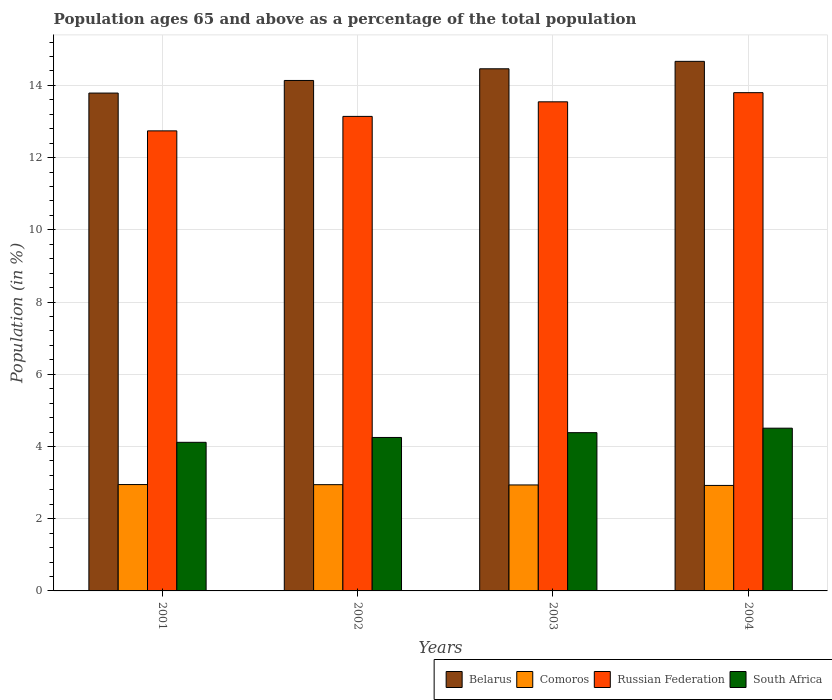How many groups of bars are there?
Give a very brief answer. 4. Are the number of bars per tick equal to the number of legend labels?
Your response must be concise. Yes. Are the number of bars on each tick of the X-axis equal?
Ensure brevity in your answer.  Yes. How many bars are there on the 3rd tick from the left?
Offer a very short reply. 4. What is the label of the 1st group of bars from the left?
Provide a short and direct response. 2001. What is the percentage of the population ages 65 and above in South Africa in 2002?
Provide a succinct answer. 4.25. Across all years, what is the maximum percentage of the population ages 65 and above in Belarus?
Provide a succinct answer. 14.67. Across all years, what is the minimum percentage of the population ages 65 and above in Comoros?
Keep it short and to the point. 2.92. In which year was the percentage of the population ages 65 and above in Comoros maximum?
Provide a succinct answer. 2001. In which year was the percentage of the population ages 65 and above in Comoros minimum?
Provide a short and direct response. 2004. What is the total percentage of the population ages 65 and above in South Africa in the graph?
Make the answer very short. 17.26. What is the difference between the percentage of the population ages 65 and above in Belarus in 2001 and that in 2004?
Ensure brevity in your answer.  -0.88. What is the difference between the percentage of the population ages 65 and above in South Africa in 2003 and the percentage of the population ages 65 and above in Comoros in 2002?
Give a very brief answer. 1.44. What is the average percentage of the population ages 65 and above in Russian Federation per year?
Keep it short and to the point. 13.31. In the year 2003, what is the difference between the percentage of the population ages 65 and above in Comoros and percentage of the population ages 65 and above in South Africa?
Offer a very short reply. -1.45. In how many years, is the percentage of the population ages 65 and above in Belarus greater than 2.8?
Your answer should be very brief. 4. What is the ratio of the percentage of the population ages 65 and above in South Africa in 2002 to that in 2004?
Give a very brief answer. 0.94. Is the percentage of the population ages 65 and above in South Africa in 2001 less than that in 2003?
Your answer should be very brief. Yes. What is the difference between the highest and the second highest percentage of the population ages 65 and above in Russian Federation?
Your answer should be very brief. 0.25. What is the difference between the highest and the lowest percentage of the population ages 65 and above in South Africa?
Ensure brevity in your answer.  0.39. In how many years, is the percentage of the population ages 65 and above in South Africa greater than the average percentage of the population ages 65 and above in South Africa taken over all years?
Ensure brevity in your answer.  2. Is it the case that in every year, the sum of the percentage of the population ages 65 and above in Belarus and percentage of the population ages 65 and above in Comoros is greater than the sum of percentage of the population ages 65 and above in Russian Federation and percentage of the population ages 65 and above in South Africa?
Provide a short and direct response. Yes. What does the 3rd bar from the left in 2003 represents?
Provide a short and direct response. Russian Federation. What does the 1st bar from the right in 2004 represents?
Offer a terse response. South Africa. How many bars are there?
Provide a succinct answer. 16. How many years are there in the graph?
Your answer should be very brief. 4. What is the difference between two consecutive major ticks on the Y-axis?
Ensure brevity in your answer.  2. Where does the legend appear in the graph?
Ensure brevity in your answer.  Bottom right. How many legend labels are there?
Offer a terse response. 4. How are the legend labels stacked?
Make the answer very short. Horizontal. What is the title of the graph?
Provide a short and direct response. Population ages 65 and above as a percentage of the total population. Does "Kenya" appear as one of the legend labels in the graph?
Provide a short and direct response. No. What is the label or title of the X-axis?
Your response must be concise. Years. What is the label or title of the Y-axis?
Provide a short and direct response. Population (in %). What is the Population (in %) of Belarus in 2001?
Your response must be concise. 13.79. What is the Population (in %) in Comoros in 2001?
Offer a terse response. 2.95. What is the Population (in %) in Russian Federation in 2001?
Your answer should be very brief. 12.74. What is the Population (in %) in South Africa in 2001?
Keep it short and to the point. 4.12. What is the Population (in %) in Belarus in 2002?
Offer a very short reply. 14.14. What is the Population (in %) in Comoros in 2002?
Provide a succinct answer. 2.94. What is the Population (in %) of Russian Federation in 2002?
Make the answer very short. 13.14. What is the Population (in %) of South Africa in 2002?
Make the answer very short. 4.25. What is the Population (in %) of Belarus in 2003?
Your answer should be compact. 14.46. What is the Population (in %) of Comoros in 2003?
Your answer should be very brief. 2.94. What is the Population (in %) of Russian Federation in 2003?
Your response must be concise. 13.55. What is the Population (in %) in South Africa in 2003?
Offer a very short reply. 4.38. What is the Population (in %) in Belarus in 2004?
Keep it short and to the point. 14.67. What is the Population (in %) in Comoros in 2004?
Make the answer very short. 2.92. What is the Population (in %) of Russian Federation in 2004?
Keep it short and to the point. 13.8. What is the Population (in %) of South Africa in 2004?
Give a very brief answer. 4.51. Across all years, what is the maximum Population (in %) of Belarus?
Offer a terse response. 14.67. Across all years, what is the maximum Population (in %) in Comoros?
Your answer should be very brief. 2.95. Across all years, what is the maximum Population (in %) in Russian Federation?
Offer a very short reply. 13.8. Across all years, what is the maximum Population (in %) in South Africa?
Make the answer very short. 4.51. Across all years, what is the minimum Population (in %) of Belarus?
Your answer should be compact. 13.79. Across all years, what is the minimum Population (in %) of Comoros?
Offer a terse response. 2.92. Across all years, what is the minimum Population (in %) of Russian Federation?
Your response must be concise. 12.74. Across all years, what is the minimum Population (in %) of South Africa?
Provide a short and direct response. 4.12. What is the total Population (in %) in Belarus in the graph?
Your response must be concise. 57.05. What is the total Population (in %) in Comoros in the graph?
Ensure brevity in your answer.  11.75. What is the total Population (in %) of Russian Federation in the graph?
Your response must be concise. 53.23. What is the total Population (in %) in South Africa in the graph?
Give a very brief answer. 17.26. What is the difference between the Population (in %) in Belarus in 2001 and that in 2002?
Your response must be concise. -0.35. What is the difference between the Population (in %) of Comoros in 2001 and that in 2002?
Provide a succinct answer. 0. What is the difference between the Population (in %) in Russian Federation in 2001 and that in 2002?
Give a very brief answer. -0.4. What is the difference between the Population (in %) in South Africa in 2001 and that in 2002?
Provide a short and direct response. -0.13. What is the difference between the Population (in %) of Belarus in 2001 and that in 2003?
Make the answer very short. -0.67. What is the difference between the Population (in %) in Comoros in 2001 and that in 2003?
Ensure brevity in your answer.  0.01. What is the difference between the Population (in %) of Russian Federation in 2001 and that in 2003?
Give a very brief answer. -0.8. What is the difference between the Population (in %) of South Africa in 2001 and that in 2003?
Your response must be concise. -0.27. What is the difference between the Population (in %) in Belarus in 2001 and that in 2004?
Your response must be concise. -0.88. What is the difference between the Population (in %) in Comoros in 2001 and that in 2004?
Your answer should be very brief. 0.02. What is the difference between the Population (in %) in Russian Federation in 2001 and that in 2004?
Your answer should be compact. -1.06. What is the difference between the Population (in %) of South Africa in 2001 and that in 2004?
Keep it short and to the point. -0.39. What is the difference between the Population (in %) of Belarus in 2002 and that in 2003?
Make the answer very short. -0.32. What is the difference between the Population (in %) in Comoros in 2002 and that in 2003?
Offer a very short reply. 0.01. What is the difference between the Population (in %) in Russian Federation in 2002 and that in 2003?
Offer a terse response. -0.4. What is the difference between the Population (in %) of South Africa in 2002 and that in 2003?
Ensure brevity in your answer.  -0.13. What is the difference between the Population (in %) in Belarus in 2002 and that in 2004?
Keep it short and to the point. -0.53. What is the difference between the Population (in %) in Comoros in 2002 and that in 2004?
Make the answer very short. 0.02. What is the difference between the Population (in %) in Russian Federation in 2002 and that in 2004?
Your response must be concise. -0.66. What is the difference between the Population (in %) in South Africa in 2002 and that in 2004?
Your answer should be compact. -0.26. What is the difference between the Population (in %) of Belarus in 2003 and that in 2004?
Your answer should be very brief. -0.21. What is the difference between the Population (in %) of Comoros in 2003 and that in 2004?
Ensure brevity in your answer.  0.01. What is the difference between the Population (in %) of Russian Federation in 2003 and that in 2004?
Provide a short and direct response. -0.25. What is the difference between the Population (in %) of South Africa in 2003 and that in 2004?
Your response must be concise. -0.12. What is the difference between the Population (in %) of Belarus in 2001 and the Population (in %) of Comoros in 2002?
Make the answer very short. 10.85. What is the difference between the Population (in %) in Belarus in 2001 and the Population (in %) in Russian Federation in 2002?
Offer a terse response. 0.65. What is the difference between the Population (in %) in Belarus in 2001 and the Population (in %) in South Africa in 2002?
Make the answer very short. 9.54. What is the difference between the Population (in %) in Comoros in 2001 and the Population (in %) in Russian Federation in 2002?
Your answer should be compact. -10.2. What is the difference between the Population (in %) in Comoros in 2001 and the Population (in %) in South Africa in 2002?
Your answer should be very brief. -1.3. What is the difference between the Population (in %) of Russian Federation in 2001 and the Population (in %) of South Africa in 2002?
Your answer should be compact. 8.49. What is the difference between the Population (in %) of Belarus in 2001 and the Population (in %) of Comoros in 2003?
Make the answer very short. 10.85. What is the difference between the Population (in %) of Belarus in 2001 and the Population (in %) of Russian Federation in 2003?
Keep it short and to the point. 0.24. What is the difference between the Population (in %) in Belarus in 2001 and the Population (in %) in South Africa in 2003?
Your answer should be very brief. 9.41. What is the difference between the Population (in %) of Comoros in 2001 and the Population (in %) of Russian Federation in 2003?
Keep it short and to the point. -10.6. What is the difference between the Population (in %) in Comoros in 2001 and the Population (in %) in South Africa in 2003?
Provide a short and direct response. -1.44. What is the difference between the Population (in %) of Russian Federation in 2001 and the Population (in %) of South Africa in 2003?
Ensure brevity in your answer.  8.36. What is the difference between the Population (in %) of Belarus in 2001 and the Population (in %) of Comoros in 2004?
Ensure brevity in your answer.  10.87. What is the difference between the Population (in %) of Belarus in 2001 and the Population (in %) of Russian Federation in 2004?
Offer a terse response. -0.01. What is the difference between the Population (in %) in Belarus in 2001 and the Population (in %) in South Africa in 2004?
Offer a very short reply. 9.28. What is the difference between the Population (in %) of Comoros in 2001 and the Population (in %) of Russian Federation in 2004?
Offer a terse response. -10.85. What is the difference between the Population (in %) in Comoros in 2001 and the Population (in %) in South Africa in 2004?
Your response must be concise. -1.56. What is the difference between the Population (in %) of Russian Federation in 2001 and the Population (in %) of South Africa in 2004?
Offer a terse response. 8.23. What is the difference between the Population (in %) of Belarus in 2002 and the Population (in %) of Comoros in 2003?
Give a very brief answer. 11.2. What is the difference between the Population (in %) in Belarus in 2002 and the Population (in %) in Russian Federation in 2003?
Offer a terse response. 0.59. What is the difference between the Population (in %) of Belarus in 2002 and the Population (in %) of South Africa in 2003?
Offer a very short reply. 9.75. What is the difference between the Population (in %) in Comoros in 2002 and the Population (in %) in Russian Federation in 2003?
Make the answer very short. -10.6. What is the difference between the Population (in %) of Comoros in 2002 and the Population (in %) of South Africa in 2003?
Give a very brief answer. -1.44. What is the difference between the Population (in %) in Russian Federation in 2002 and the Population (in %) in South Africa in 2003?
Provide a succinct answer. 8.76. What is the difference between the Population (in %) in Belarus in 2002 and the Population (in %) in Comoros in 2004?
Your answer should be very brief. 11.22. What is the difference between the Population (in %) in Belarus in 2002 and the Population (in %) in Russian Federation in 2004?
Provide a short and direct response. 0.34. What is the difference between the Population (in %) in Belarus in 2002 and the Population (in %) in South Africa in 2004?
Give a very brief answer. 9.63. What is the difference between the Population (in %) in Comoros in 2002 and the Population (in %) in Russian Federation in 2004?
Your answer should be compact. -10.86. What is the difference between the Population (in %) in Comoros in 2002 and the Population (in %) in South Africa in 2004?
Your response must be concise. -1.56. What is the difference between the Population (in %) in Russian Federation in 2002 and the Population (in %) in South Africa in 2004?
Your answer should be compact. 8.63. What is the difference between the Population (in %) in Belarus in 2003 and the Population (in %) in Comoros in 2004?
Offer a very short reply. 11.54. What is the difference between the Population (in %) in Belarus in 2003 and the Population (in %) in Russian Federation in 2004?
Offer a very short reply. 0.66. What is the difference between the Population (in %) of Belarus in 2003 and the Population (in %) of South Africa in 2004?
Your response must be concise. 9.95. What is the difference between the Population (in %) in Comoros in 2003 and the Population (in %) in Russian Federation in 2004?
Offer a terse response. -10.86. What is the difference between the Population (in %) of Comoros in 2003 and the Population (in %) of South Africa in 2004?
Provide a short and direct response. -1.57. What is the difference between the Population (in %) in Russian Federation in 2003 and the Population (in %) in South Africa in 2004?
Ensure brevity in your answer.  9.04. What is the average Population (in %) of Belarus per year?
Offer a terse response. 14.26. What is the average Population (in %) in Comoros per year?
Keep it short and to the point. 2.94. What is the average Population (in %) in Russian Federation per year?
Make the answer very short. 13.31. What is the average Population (in %) in South Africa per year?
Keep it short and to the point. 4.31. In the year 2001, what is the difference between the Population (in %) of Belarus and Population (in %) of Comoros?
Make the answer very short. 10.84. In the year 2001, what is the difference between the Population (in %) of Belarus and Population (in %) of Russian Federation?
Your answer should be very brief. 1.05. In the year 2001, what is the difference between the Population (in %) of Belarus and Population (in %) of South Africa?
Provide a succinct answer. 9.67. In the year 2001, what is the difference between the Population (in %) of Comoros and Population (in %) of Russian Federation?
Ensure brevity in your answer.  -9.8. In the year 2001, what is the difference between the Population (in %) of Comoros and Population (in %) of South Africa?
Ensure brevity in your answer.  -1.17. In the year 2001, what is the difference between the Population (in %) of Russian Federation and Population (in %) of South Africa?
Offer a very short reply. 8.63. In the year 2002, what is the difference between the Population (in %) in Belarus and Population (in %) in Comoros?
Provide a short and direct response. 11.2. In the year 2002, what is the difference between the Population (in %) of Belarus and Population (in %) of South Africa?
Make the answer very short. 9.89. In the year 2002, what is the difference between the Population (in %) of Comoros and Population (in %) of Russian Federation?
Make the answer very short. -10.2. In the year 2002, what is the difference between the Population (in %) of Comoros and Population (in %) of South Africa?
Your response must be concise. -1.31. In the year 2002, what is the difference between the Population (in %) in Russian Federation and Population (in %) in South Africa?
Your answer should be compact. 8.89. In the year 2003, what is the difference between the Population (in %) of Belarus and Population (in %) of Comoros?
Give a very brief answer. 11.53. In the year 2003, what is the difference between the Population (in %) of Belarus and Population (in %) of Russian Federation?
Offer a terse response. 0.91. In the year 2003, what is the difference between the Population (in %) of Belarus and Population (in %) of South Africa?
Provide a short and direct response. 10.08. In the year 2003, what is the difference between the Population (in %) of Comoros and Population (in %) of Russian Federation?
Ensure brevity in your answer.  -10.61. In the year 2003, what is the difference between the Population (in %) of Comoros and Population (in %) of South Africa?
Give a very brief answer. -1.45. In the year 2003, what is the difference between the Population (in %) of Russian Federation and Population (in %) of South Africa?
Provide a succinct answer. 9.16. In the year 2004, what is the difference between the Population (in %) in Belarus and Population (in %) in Comoros?
Provide a short and direct response. 11.74. In the year 2004, what is the difference between the Population (in %) in Belarus and Population (in %) in Russian Federation?
Keep it short and to the point. 0.87. In the year 2004, what is the difference between the Population (in %) in Belarus and Population (in %) in South Africa?
Provide a short and direct response. 10.16. In the year 2004, what is the difference between the Population (in %) of Comoros and Population (in %) of Russian Federation?
Offer a very short reply. -10.88. In the year 2004, what is the difference between the Population (in %) in Comoros and Population (in %) in South Africa?
Your answer should be compact. -1.59. In the year 2004, what is the difference between the Population (in %) in Russian Federation and Population (in %) in South Africa?
Give a very brief answer. 9.29. What is the ratio of the Population (in %) in Belarus in 2001 to that in 2002?
Provide a succinct answer. 0.98. What is the ratio of the Population (in %) of Russian Federation in 2001 to that in 2002?
Keep it short and to the point. 0.97. What is the ratio of the Population (in %) of South Africa in 2001 to that in 2002?
Offer a very short reply. 0.97. What is the ratio of the Population (in %) of Belarus in 2001 to that in 2003?
Keep it short and to the point. 0.95. What is the ratio of the Population (in %) of Russian Federation in 2001 to that in 2003?
Give a very brief answer. 0.94. What is the ratio of the Population (in %) in South Africa in 2001 to that in 2003?
Make the answer very short. 0.94. What is the ratio of the Population (in %) of Belarus in 2001 to that in 2004?
Offer a very short reply. 0.94. What is the ratio of the Population (in %) of Comoros in 2001 to that in 2004?
Give a very brief answer. 1.01. What is the ratio of the Population (in %) of Russian Federation in 2001 to that in 2004?
Give a very brief answer. 0.92. What is the ratio of the Population (in %) in South Africa in 2001 to that in 2004?
Provide a succinct answer. 0.91. What is the ratio of the Population (in %) in Belarus in 2002 to that in 2003?
Provide a succinct answer. 0.98. What is the ratio of the Population (in %) of Comoros in 2002 to that in 2003?
Make the answer very short. 1. What is the ratio of the Population (in %) of Russian Federation in 2002 to that in 2003?
Make the answer very short. 0.97. What is the ratio of the Population (in %) of South Africa in 2002 to that in 2003?
Provide a succinct answer. 0.97. What is the ratio of the Population (in %) of Belarus in 2002 to that in 2004?
Ensure brevity in your answer.  0.96. What is the ratio of the Population (in %) in Comoros in 2002 to that in 2004?
Offer a terse response. 1.01. What is the ratio of the Population (in %) in South Africa in 2002 to that in 2004?
Provide a succinct answer. 0.94. What is the ratio of the Population (in %) in Belarus in 2003 to that in 2004?
Keep it short and to the point. 0.99. What is the ratio of the Population (in %) in Comoros in 2003 to that in 2004?
Keep it short and to the point. 1. What is the ratio of the Population (in %) of Russian Federation in 2003 to that in 2004?
Your answer should be compact. 0.98. What is the ratio of the Population (in %) in South Africa in 2003 to that in 2004?
Offer a very short reply. 0.97. What is the difference between the highest and the second highest Population (in %) of Belarus?
Your response must be concise. 0.21. What is the difference between the highest and the second highest Population (in %) of Comoros?
Give a very brief answer. 0. What is the difference between the highest and the second highest Population (in %) of Russian Federation?
Ensure brevity in your answer.  0.25. What is the difference between the highest and the second highest Population (in %) of South Africa?
Your answer should be very brief. 0.12. What is the difference between the highest and the lowest Population (in %) of Belarus?
Offer a terse response. 0.88. What is the difference between the highest and the lowest Population (in %) in Comoros?
Your answer should be compact. 0.02. What is the difference between the highest and the lowest Population (in %) of Russian Federation?
Provide a succinct answer. 1.06. What is the difference between the highest and the lowest Population (in %) of South Africa?
Ensure brevity in your answer.  0.39. 